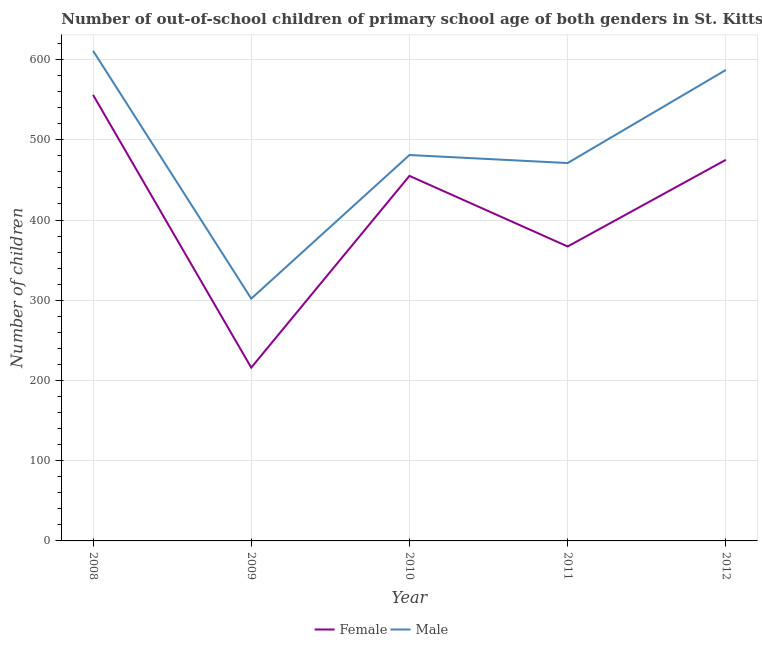What is the number of male out-of-school students in 2008?
Your answer should be very brief. 611. Across all years, what is the maximum number of female out-of-school students?
Make the answer very short. 556. Across all years, what is the minimum number of female out-of-school students?
Make the answer very short. 216. In which year was the number of male out-of-school students maximum?
Make the answer very short. 2008. What is the total number of male out-of-school students in the graph?
Your answer should be very brief. 2452. What is the difference between the number of female out-of-school students in 2010 and that in 2011?
Make the answer very short. 88. What is the difference between the number of male out-of-school students in 2008 and the number of female out-of-school students in 2012?
Give a very brief answer. 136. What is the average number of male out-of-school students per year?
Offer a very short reply. 490.4. In the year 2008, what is the difference between the number of male out-of-school students and number of female out-of-school students?
Offer a terse response. 55. What is the ratio of the number of female out-of-school students in 2008 to that in 2011?
Give a very brief answer. 1.51. What is the difference between the highest and the lowest number of female out-of-school students?
Your answer should be compact. 340. Is the sum of the number of male out-of-school students in 2009 and 2012 greater than the maximum number of female out-of-school students across all years?
Make the answer very short. Yes. Does the number of female out-of-school students monotonically increase over the years?
Provide a short and direct response. No. Is the number of male out-of-school students strictly greater than the number of female out-of-school students over the years?
Offer a terse response. Yes. Does the graph contain any zero values?
Provide a succinct answer. No. Does the graph contain grids?
Make the answer very short. Yes. Where does the legend appear in the graph?
Offer a terse response. Bottom center. How many legend labels are there?
Offer a terse response. 2. What is the title of the graph?
Offer a very short reply. Number of out-of-school children of primary school age of both genders in St. Kitts and Nevis. What is the label or title of the X-axis?
Your response must be concise. Year. What is the label or title of the Y-axis?
Give a very brief answer. Number of children. What is the Number of children in Female in 2008?
Ensure brevity in your answer.  556. What is the Number of children in Male in 2008?
Offer a terse response. 611. What is the Number of children in Female in 2009?
Keep it short and to the point. 216. What is the Number of children in Male in 2009?
Make the answer very short. 302. What is the Number of children of Female in 2010?
Offer a terse response. 455. What is the Number of children in Male in 2010?
Your answer should be very brief. 481. What is the Number of children of Female in 2011?
Give a very brief answer. 367. What is the Number of children of Male in 2011?
Your answer should be very brief. 471. What is the Number of children of Female in 2012?
Your answer should be compact. 475. What is the Number of children in Male in 2012?
Offer a terse response. 587. Across all years, what is the maximum Number of children in Female?
Your response must be concise. 556. Across all years, what is the maximum Number of children of Male?
Your answer should be very brief. 611. Across all years, what is the minimum Number of children in Female?
Provide a short and direct response. 216. Across all years, what is the minimum Number of children of Male?
Offer a very short reply. 302. What is the total Number of children in Female in the graph?
Keep it short and to the point. 2069. What is the total Number of children in Male in the graph?
Ensure brevity in your answer.  2452. What is the difference between the Number of children of Female in 2008 and that in 2009?
Keep it short and to the point. 340. What is the difference between the Number of children of Male in 2008 and that in 2009?
Offer a very short reply. 309. What is the difference between the Number of children in Female in 2008 and that in 2010?
Provide a succinct answer. 101. What is the difference between the Number of children of Male in 2008 and that in 2010?
Offer a terse response. 130. What is the difference between the Number of children of Female in 2008 and that in 2011?
Provide a short and direct response. 189. What is the difference between the Number of children in Male in 2008 and that in 2011?
Offer a very short reply. 140. What is the difference between the Number of children in Female in 2009 and that in 2010?
Give a very brief answer. -239. What is the difference between the Number of children of Male in 2009 and that in 2010?
Give a very brief answer. -179. What is the difference between the Number of children of Female in 2009 and that in 2011?
Your answer should be very brief. -151. What is the difference between the Number of children in Male in 2009 and that in 2011?
Provide a succinct answer. -169. What is the difference between the Number of children in Female in 2009 and that in 2012?
Offer a terse response. -259. What is the difference between the Number of children of Male in 2009 and that in 2012?
Ensure brevity in your answer.  -285. What is the difference between the Number of children in Male in 2010 and that in 2011?
Provide a succinct answer. 10. What is the difference between the Number of children in Female in 2010 and that in 2012?
Make the answer very short. -20. What is the difference between the Number of children of Male in 2010 and that in 2012?
Provide a succinct answer. -106. What is the difference between the Number of children in Female in 2011 and that in 2012?
Provide a short and direct response. -108. What is the difference between the Number of children in Male in 2011 and that in 2012?
Offer a very short reply. -116. What is the difference between the Number of children in Female in 2008 and the Number of children in Male in 2009?
Your response must be concise. 254. What is the difference between the Number of children of Female in 2008 and the Number of children of Male in 2011?
Your answer should be compact. 85. What is the difference between the Number of children in Female in 2008 and the Number of children in Male in 2012?
Your answer should be very brief. -31. What is the difference between the Number of children in Female in 2009 and the Number of children in Male in 2010?
Make the answer very short. -265. What is the difference between the Number of children of Female in 2009 and the Number of children of Male in 2011?
Your answer should be compact. -255. What is the difference between the Number of children in Female in 2009 and the Number of children in Male in 2012?
Keep it short and to the point. -371. What is the difference between the Number of children of Female in 2010 and the Number of children of Male in 2012?
Provide a succinct answer. -132. What is the difference between the Number of children of Female in 2011 and the Number of children of Male in 2012?
Make the answer very short. -220. What is the average Number of children in Female per year?
Your answer should be compact. 413.8. What is the average Number of children of Male per year?
Provide a short and direct response. 490.4. In the year 2008, what is the difference between the Number of children in Female and Number of children in Male?
Your answer should be very brief. -55. In the year 2009, what is the difference between the Number of children of Female and Number of children of Male?
Your answer should be very brief. -86. In the year 2011, what is the difference between the Number of children of Female and Number of children of Male?
Provide a short and direct response. -104. In the year 2012, what is the difference between the Number of children in Female and Number of children in Male?
Your answer should be compact. -112. What is the ratio of the Number of children of Female in 2008 to that in 2009?
Offer a very short reply. 2.57. What is the ratio of the Number of children of Male in 2008 to that in 2009?
Keep it short and to the point. 2.02. What is the ratio of the Number of children in Female in 2008 to that in 2010?
Make the answer very short. 1.22. What is the ratio of the Number of children of Male in 2008 to that in 2010?
Your response must be concise. 1.27. What is the ratio of the Number of children in Female in 2008 to that in 2011?
Offer a terse response. 1.51. What is the ratio of the Number of children of Male in 2008 to that in 2011?
Give a very brief answer. 1.3. What is the ratio of the Number of children of Female in 2008 to that in 2012?
Your answer should be compact. 1.17. What is the ratio of the Number of children of Male in 2008 to that in 2012?
Offer a terse response. 1.04. What is the ratio of the Number of children of Female in 2009 to that in 2010?
Keep it short and to the point. 0.47. What is the ratio of the Number of children in Male in 2009 to that in 2010?
Provide a short and direct response. 0.63. What is the ratio of the Number of children of Female in 2009 to that in 2011?
Your answer should be very brief. 0.59. What is the ratio of the Number of children in Male in 2009 to that in 2011?
Offer a terse response. 0.64. What is the ratio of the Number of children of Female in 2009 to that in 2012?
Your answer should be very brief. 0.45. What is the ratio of the Number of children in Male in 2009 to that in 2012?
Offer a terse response. 0.51. What is the ratio of the Number of children in Female in 2010 to that in 2011?
Offer a terse response. 1.24. What is the ratio of the Number of children of Male in 2010 to that in 2011?
Give a very brief answer. 1.02. What is the ratio of the Number of children of Female in 2010 to that in 2012?
Ensure brevity in your answer.  0.96. What is the ratio of the Number of children of Male in 2010 to that in 2012?
Provide a short and direct response. 0.82. What is the ratio of the Number of children of Female in 2011 to that in 2012?
Keep it short and to the point. 0.77. What is the ratio of the Number of children of Male in 2011 to that in 2012?
Ensure brevity in your answer.  0.8. What is the difference between the highest and the second highest Number of children of Female?
Keep it short and to the point. 81. What is the difference between the highest and the lowest Number of children of Female?
Your answer should be compact. 340. What is the difference between the highest and the lowest Number of children in Male?
Give a very brief answer. 309. 